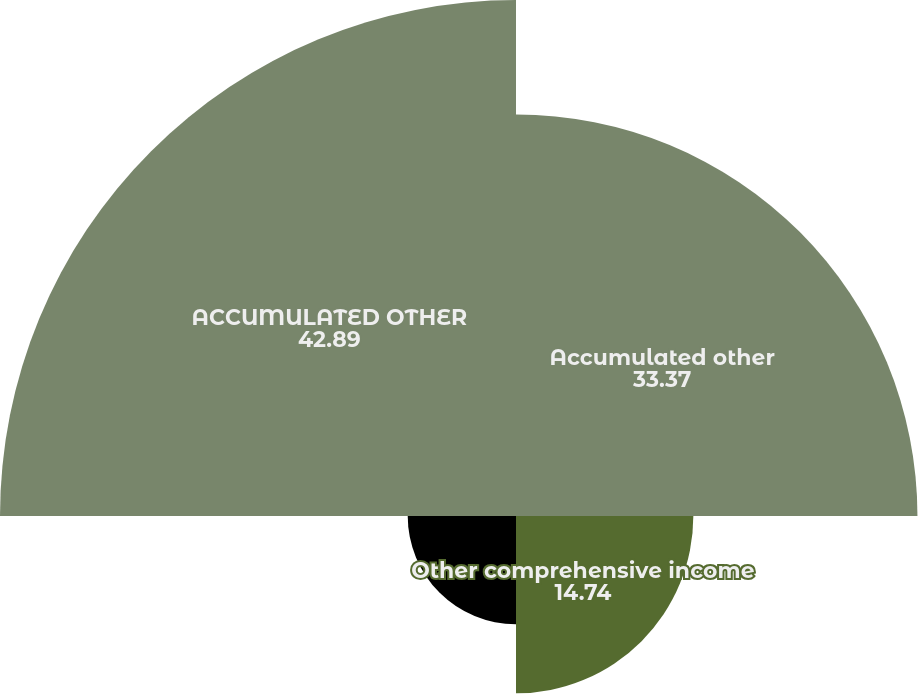<chart> <loc_0><loc_0><loc_500><loc_500><pie_chart><fcel>Accumulated other<fcel>Other comprehensive income<fcel>Amounts reclassified from<fcel>ACCUMULATED OTHER<nl><fcel>33.37%<fcel>14.74%<fcel>9.0%<fcel>42.89%<nl></chart> 